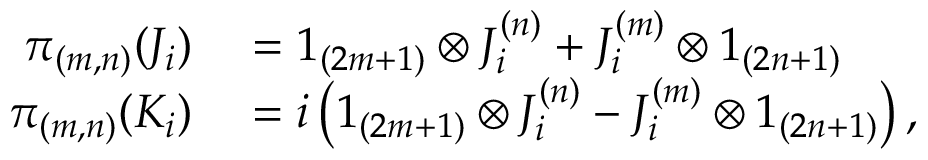<formula> <loc_0><loc_0><loc_500><loc_500>\begin{array} { r l } { \pi _ { ( m , n ) } ( J _ { i } ) } & = 1 _ { ( 2 m + 1 ) } \otimes J _ { i } ^ { ( n ) } + J _ { i } ^ { ( m ) } \otimes 1 _ { ( 2 n + 1 ) } } \\ { \pi _ { ( m , n ) } ( K _ { i } ) } & = i \left ( 1 _ { ( 2 m + 1 ) } \otimes J _ { i } ^ { ( n ) } - J _ { i } ^ { ( m ) } \otimes 1 _ { ( 2 n + 1 ) } \right ) , } \end{array}</formula> 